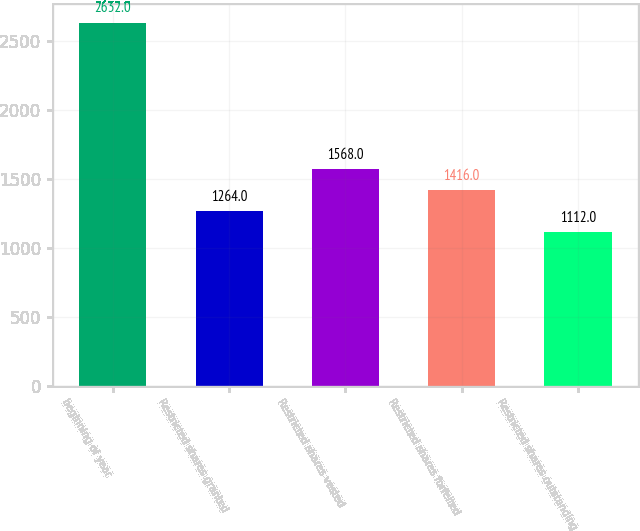Convert chart. <chart><loc_0><loc_0><loc_500><loc_500><bar_chart><fcel>beginning of year<fcel>Restricted shares granted<fcel>Restricted shares vested<fcel>Restricted shares forfeited<fcel>Restricted shares outstanding<nl><fcel>2632<fcel>1264<fcel>1568<fcel>1416<fcel>1112<nl></chart> 